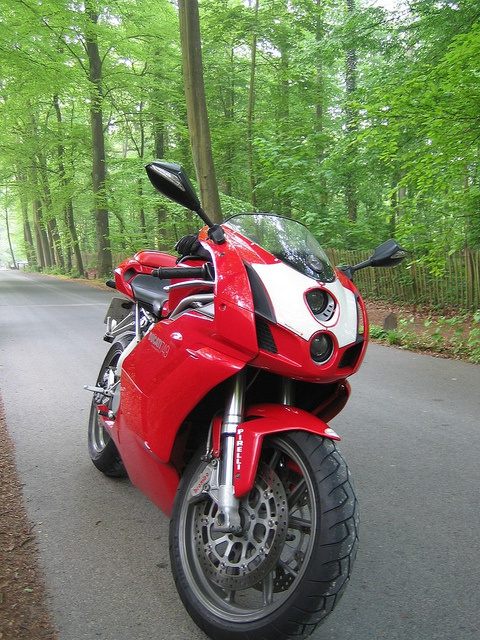Describe the objects in this image and their specific colors. I can see a motorcycle in green, black, gray, brown, and white tones in this image. 